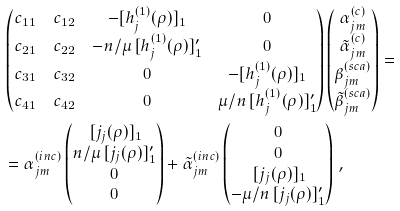<formula> <loc_0><loc_0><loc_500><loc_500>& \begin{pmatrix} c _ { 1 1 } & c _ { 1 2 } & - [ h _ { j } ^ { ( 1 ) } ( \rho ) ] _ { 1 } & 0 \\ c _ { 2 1 } & c _ { 2 2 } & - n / \mu \, [ h _ { j } ^ { ( 1 ) } ( \rho ) ] ^ { \prime } _ { 1 } & 0 \\ c _ { 3 1 } & c _ { 3 2 } & 0 & - [ h _ { j } ^ { ( 1 ) } ( \rho ) ] _ { 1 } \\ c _ { 4 1 } & c _ { 4 2 } & 0 & \mu / n \, [ h _ { j } ^ { ( 1 ) } ( \rho ) ] ^ { \prime } _ { 1 } \end{pmatrix} \begin{pmatrix} \alpha _ { j m } ^ { ( c ) } \\ \tilde { \alpha } _ { j m } ^ { ( c ) } \\ \beta _ { j m } ^ { ( s c a ) } \\ \tilde { \beta } _ { j m } ^ { ( s c a ) } \\ \end{pmatrix} = \\ & = \alpha _ { j m } ^ { ( i n c ) } \begin{pmatrix} \, [ j _ { j } ( \rho ) ] _ { 1 } \\ n / \mu \, [ j _ { j } ( \rho ) ] ^ { \prime } _ { 1 } \\ 0 \\ 0 \end{pmatrix} + \tilde { \alpha } _ { j m } ^ { ( i n c ) } \begin{pmatrix} 0 \\ 0 \\ \, [ j _ { j } ( \rho ) ] _ { 1 } \\ - \mu / n \, [ j _ { j } ( \rho ) ] ^ { \prime } _ { 1 } \end{pmatrix} \, ,</formula> 